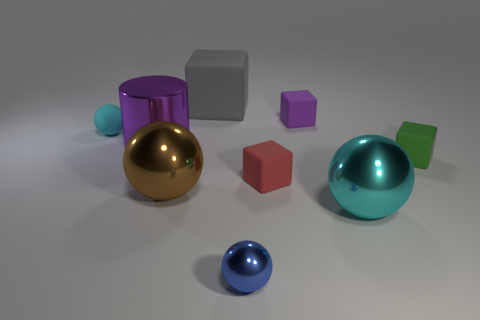What number of blue things are large shiny things or tiny rubber objects?
Your answer should be very brief. 0. What number of small matte cubes are the same color as the cylinder?
Keep it short and to the point. 1. Do the tiny purple object and the red block have the same material?
Provide a short and direct response. Yes. How many rubber blocks are on the right side of the tiny ball in front of the brown ball?
Give a very brief answer. 3. Is the gray matte cube the same size as the blue thing?
Your answer should be very brief. No. How many red cylinders have the same material as the blue object?
Ensure brevity in your answer.  0. There is another matte thing that is the same shape as the small blue object; what is its size?
Provide a short and direct response. Small. Does the cyan object that is behind the large purple thing have the same shape as the small red object?
Offer a terse response. No. What shape is the cyan object to the right of the small matte thing that is in front of the small green cube?
Your response must be concise. Sphere. Are there any other things that are the same shape as the blue thing?
Keep it short and to the point. Yes. 